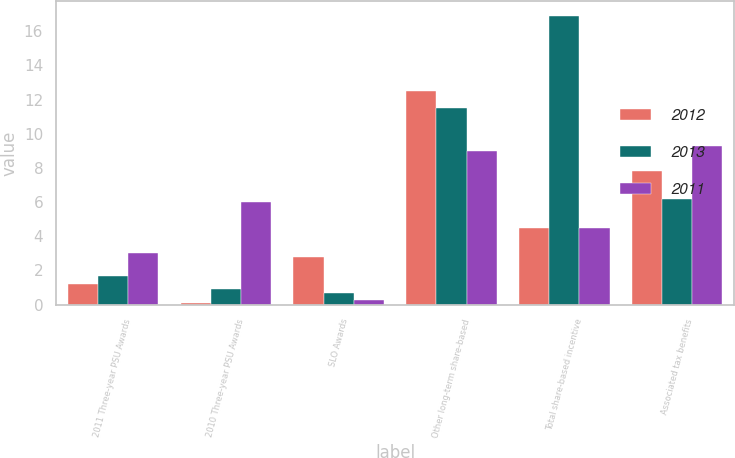Convert chart. <chart><loc_0><loc_0><loc_500><loc_500><stacked_bar_chart><ecel><fcel>2011 Three-year PSU Awards<fcel>2010 Three-year PSU Awards<fcel>SLO Awards<fcel>Other long-term share-based<fcel>Total share-based incentive<fcel>Associated tax benefits<nl><fcel>2012<fcel>1.2<fcel>0.1<fcel>2.8<fcel>12.5<fcel>4.5<fcel>7.8<nl><fcel>2013<fcel>1.7<fcel>0.9<fcel>0.7<fcel>11.5<fcel>16.9<fcel>6.2<nl><fcel>2011<fcel>3<fcel>6<fcel>0.3<fcel>9<fcel>4.5<fcel>9.3<nl></chart> 